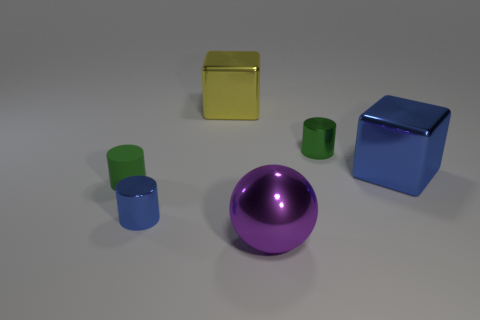There is a cylinder that is the same color as the matte thing; what material is it?
Offer a very short reply. Metal. Is there anything else of the same color as the matte cylinder?
Your response must be concise. Yes. There is a tiny green cylinder that is in front of the tiny green thing right of the small matte object that is in front of the green metal cylinder; what is its material?
Offer a terse response. Rubber. How many large purple things are in front of the tiny metallic cylinder to the left of the yellow metal cube that is on the left side of the sphere?
Offer a very short reply. 1. What color is the metallic cylinder that is in front of the small matte cylinder?
Give a very brief answer. Blue. There is a large object that is both right of the yellow metal block and behind the small blue object; what is its material?
Keep it short and to the point. Metal. There is a small green cylinder that is right of the large yellow block; what number of objects are to the left of it?
Ensure brevity in your answer.  4. The tiny rubber object is what shape?
Ensure brevity in your answer.  Cylinder. There is a yellow object that is made of the same material as the large sphere; what is its shape?
Your answer should be compact. Cube. There is a blue thing behind the small blue shiny cylinder; is it the same shape as the yellow metallic thing?
Offer a very short reply. Yes. 